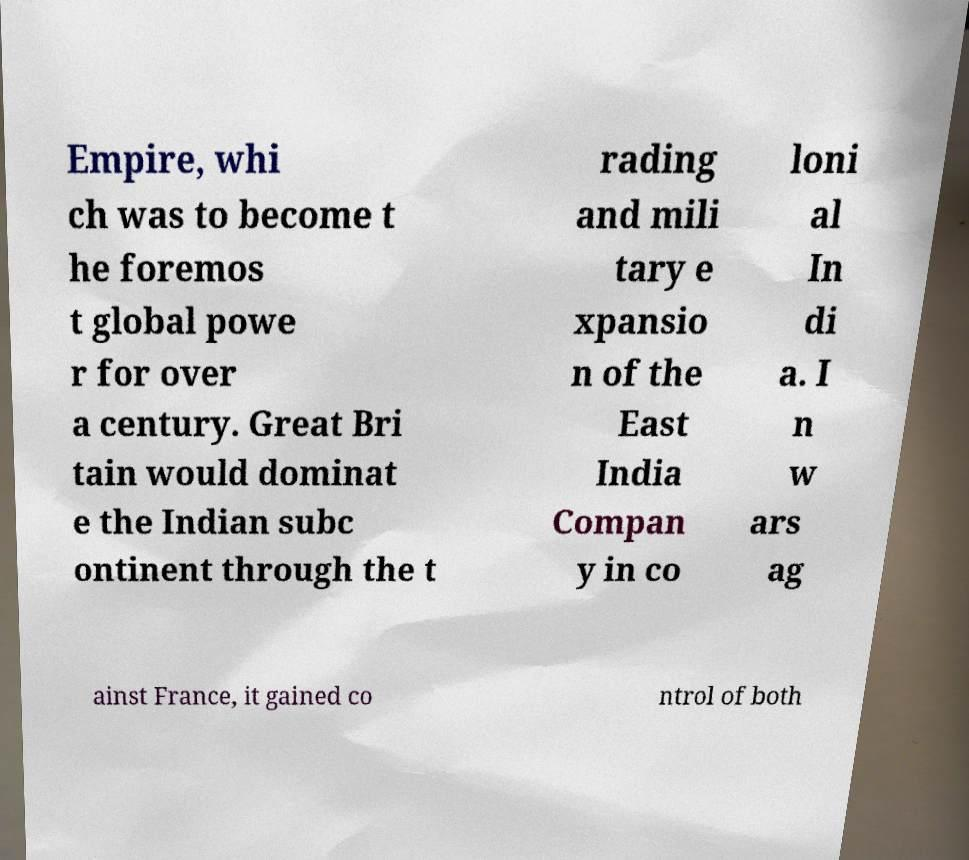Can you accurately transcribe the text from the provided image for me? Empire, whi ch was to become t he foremos t global powe r for over a century. Great Bri tain would dominat e the Indian subc ontinent through the t rading and mili tary e xpansio n of the East India Compan y in co loni al In di a. I n w ars ag ainst France, it gained co ntrol of both 